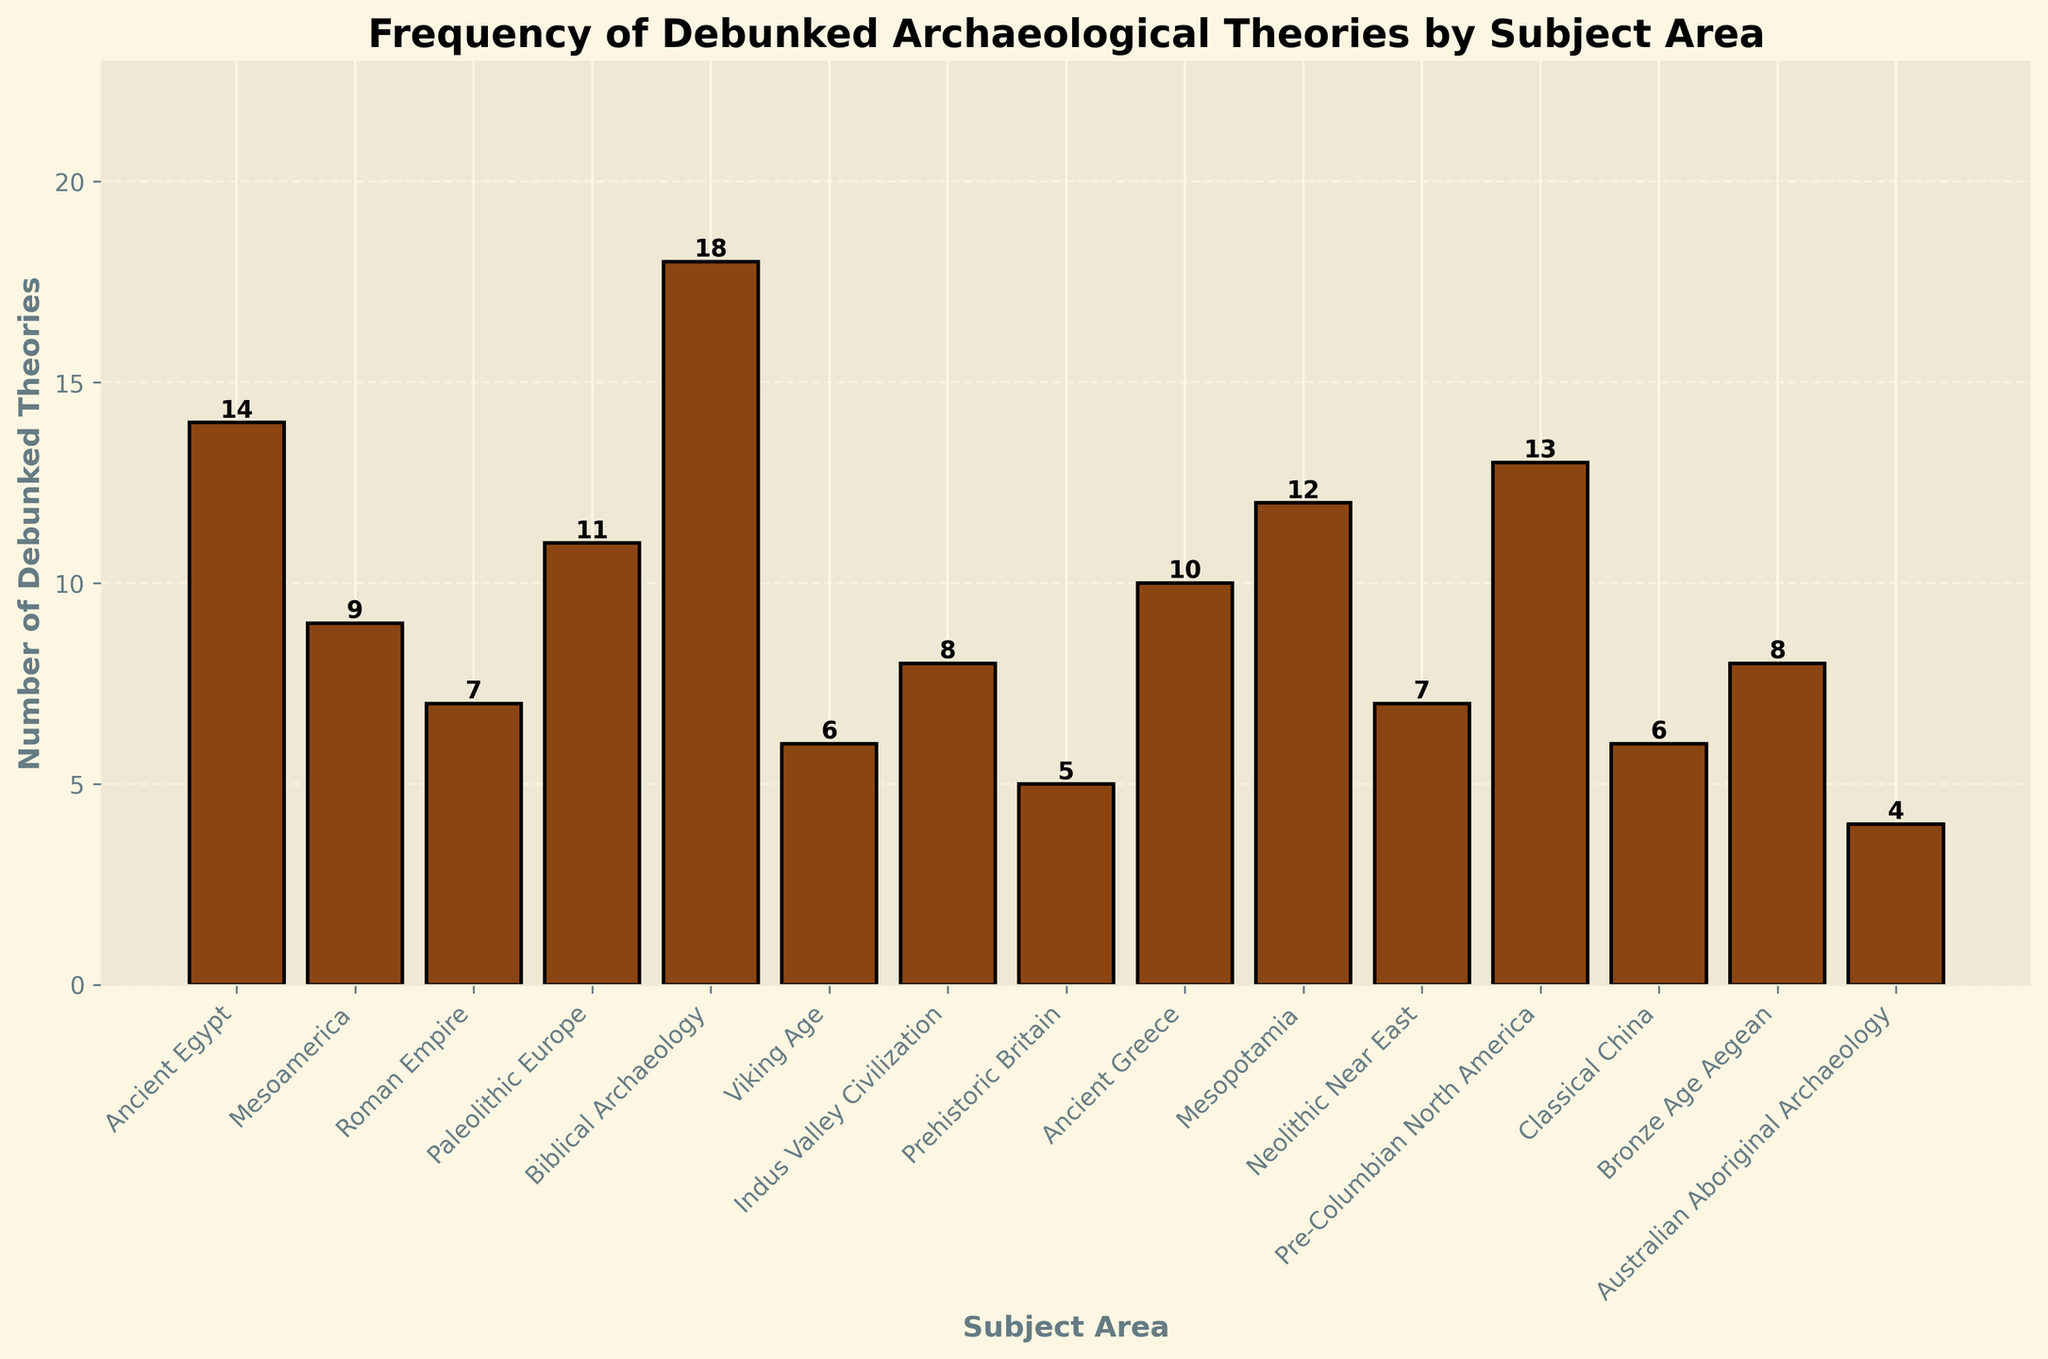How many more debunked theories are there in Biblical Archaeology compared to Viking Age? According to the figure, Biblical Archaeology has 18 debunked theories, whereas Viking Age has 6. The difference between them is 18 - 6 = 12.
Answer: 12 Which subject area has the least number of debunked theories, and how many are there? From the bar chart, Australian Aboriginal Archaeology has the shortest bar, indicating the least number of debunked theories. The value is 4.
Answer: Australian Aboriginal Archaeology, 4 What is the total number of debunked theories for the subject areas of Ancient Egypt, Mesoamerica, and Roman Empire combined? Ancient Egypt has 14, Mesoamerica has 9, and Roman Empire has 7. The total number of debunked theories is 14 + 9 + 7 = 30.
Answer: 30 Which subject area has a higher number of debunked theories: Mesopotamia or Neolithic Near East? By comparing the heights of the bars, Mesopotamia has 12 while Neolithic Near East has 7. Therefore, Mesopotamia has a higher number of debunked theories.
Answer: Mesopotamia What is the average number of debunked theories across all subject areas? Sum the number of debunked theories across all subject areas: 14 + 9 + 7 + 11 + 18 + 6 + 8 + 5 + 10 + 12 + 7 + 13 + 6 + 8 + 4 = 138. There are 15 subject areas, so the average is 138 / 15 = 9.2.
Answer: 9.2 Which subject areas have exactly more than 10 but fewer than 15 debunked theories? By examining the bars with heights between 10 and 15, the relevant subject areas are Ancient Greece (10), Mesopotamia (12), and Pre-Columbian North America (13).
Answer: Ancient Greece, Mesopotamia, Pre-Columbian North America If we combine the debunked theories of Ancient Greece, Mesopotamia, and Paleolithic Europe, what percentage of the total debunked theories do they represent? Sum of debunked theories for these areas: 10 (Ancient Greece) + 12 (Mesopotamia) + 11 (Paleolithic Europe) = 33. Total debunked theories across all subject areas = 138. The percentage is (33 / 138) * 100 ≈ 23.91%.
Answer: ~23.91% Identify the subject areas that have fewer debunked theories than the average number. The average number of debunked theories is 9.2. If we look at each bar individually, the subject areas with fewer than 9.2 debunked theories are: Mesoamerica (9), Roman Empire (7), Viking Age (6), Indus Valley Civilization (8), Prehistoric Britain (5), Neolithic Near East (7), Classical China (6), and Australian Aboriginal Archaeology (4).
Answer: Mesoamerica, Roman Empire, Viking Age, Indus Valley Civilization, Prehistoric Britain, Neolithic Near East, Classical China, Australian Aboriginal Archaeology Between Pre-Columbian North America and Ancient Greece, which one has a higher number of debunked theories and by how much? Pre-Columbian North America has 13 debunked theories and Ancient Greece has 10. The difference is 13 - 10 = 3.
Answer: Pre-Columbian North America, 3 